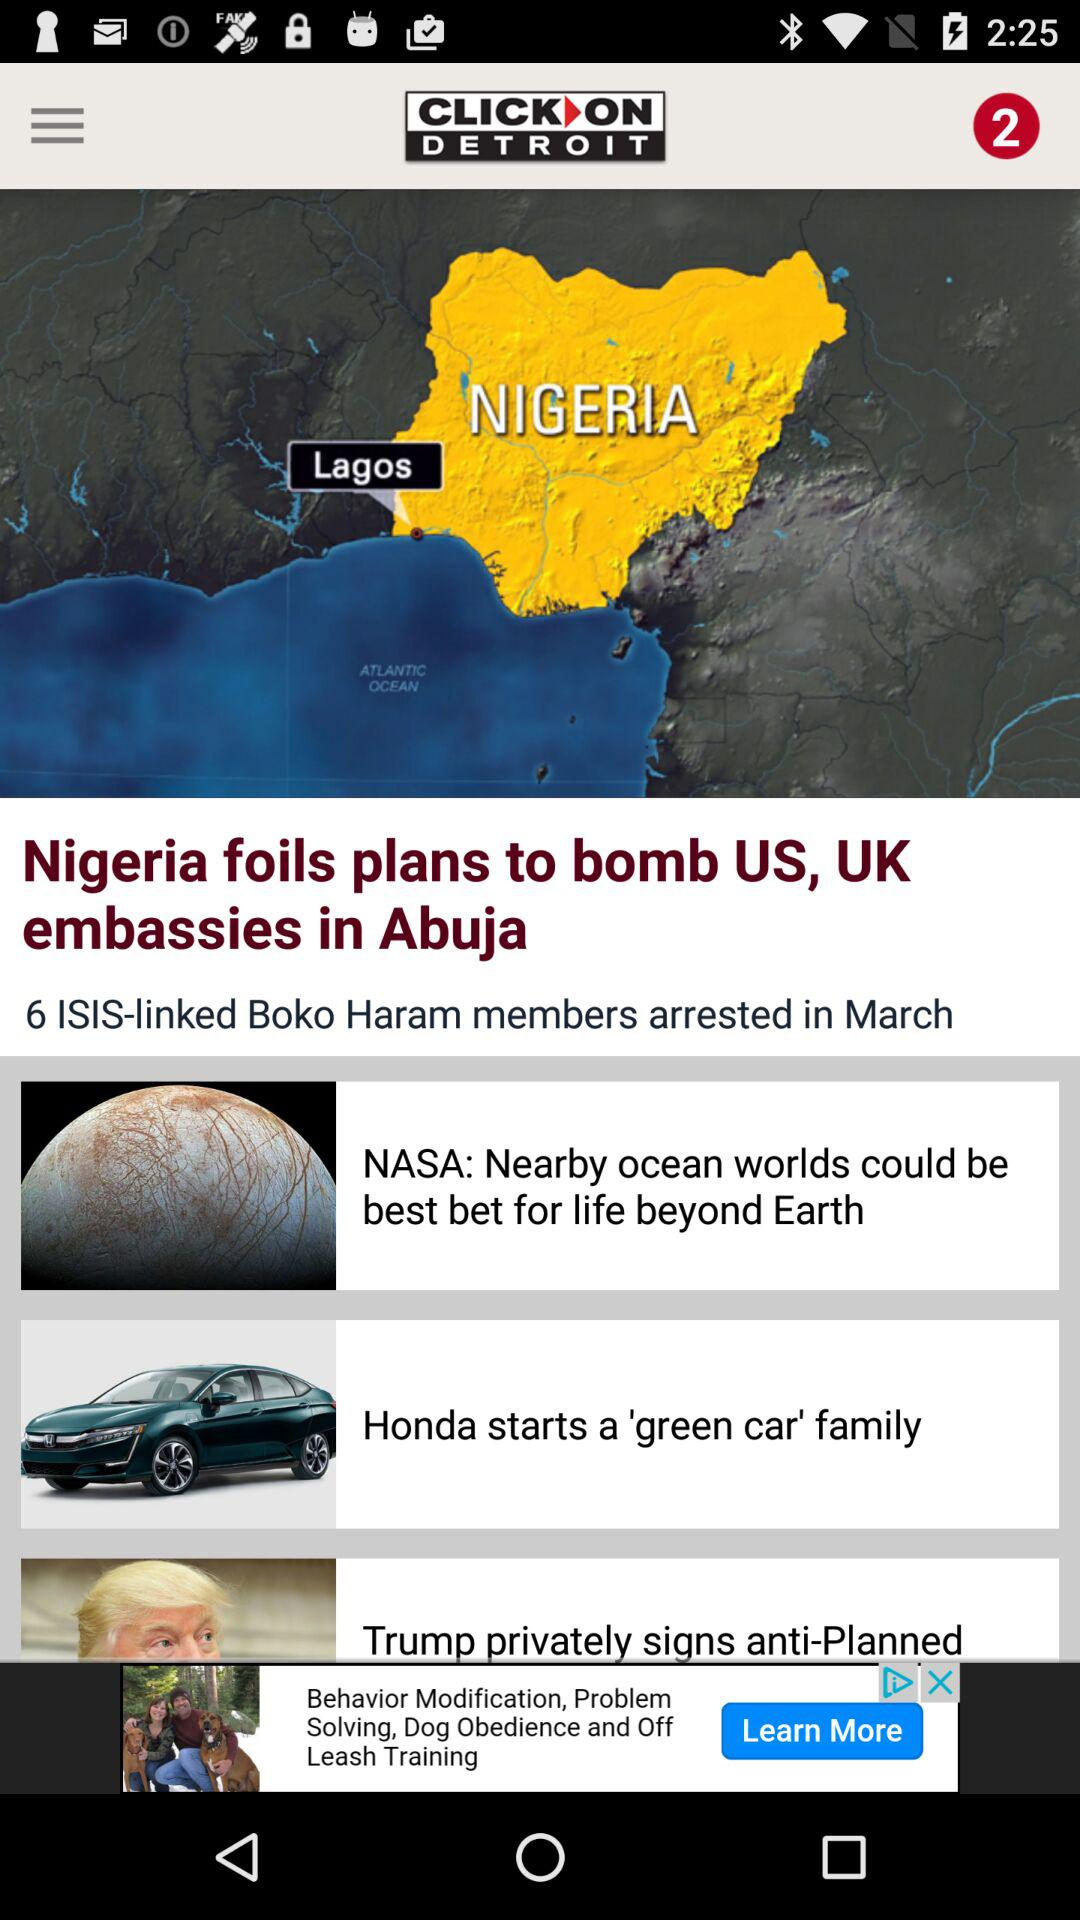Who has started a 'green car' family? A 'green car' family has been started by Honda. 